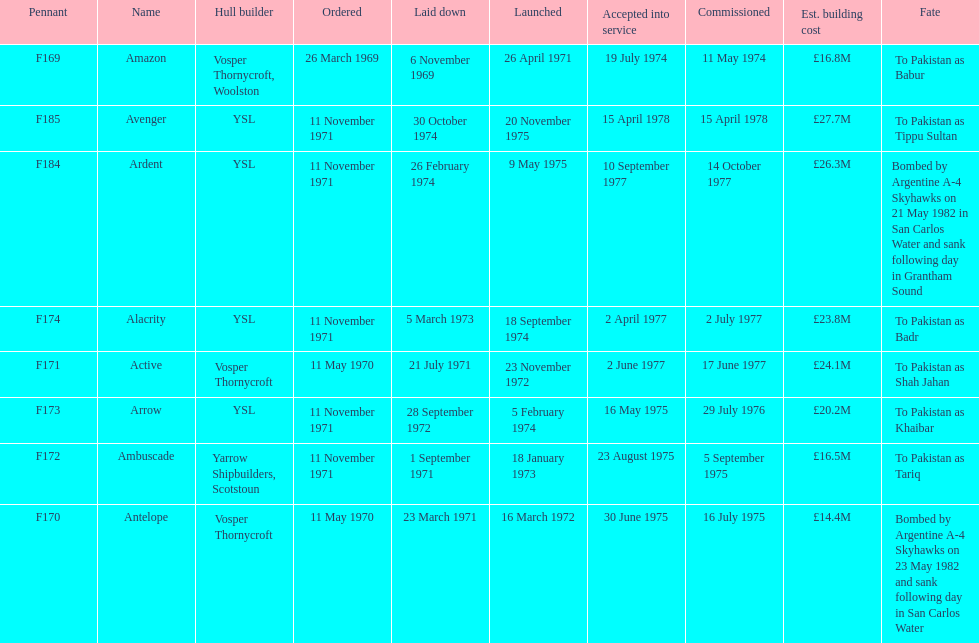Parse the full table. {'header': ['Pennant', 'Name', 'Hull builder', 'Ordered', 'Laid down', 'Launched', 'Accepted into service', 'Commissioned', 'Est. building cost', 'Fate'], 'rows': [['F169', 'Amazon', 'Vosper Thornycroft, Woolston', '26 March 1969', '6 November 1969', '26 April 1971', '19 July 1974', '11 May 1974', '£16.8M', 'To Pakistan as Babur'], ['F185', 'Avenger', 'YSL', '11 November 1971', '30 October 1974', '20 November 1975', '15 April 1978', '15 April 1978', '£27.7M', 'To Pakistan as Tippu Sultan'], ['F184', 'Ardent', 'YSL', '11 November 1971', '26 February 1974', '9 May 1975', '10 September 1977', '14 October 1977', '£26.3M', 'Bombed by Argentine A-4 Skyhawks on 21 May 1982 in San Carlos Water and sank following day in Grantham Sound'], ['F174', 'Alacrity', 'YSL', '11 November 1971', '5 March 1973', '18 September 1974', '2 April 1977', '2 July 1977', '£23.8M', 'To Pakistan as Badr'], ['F171', 'Active', 'Vosper Thornycroft', '11 May 1970', '21 July 1971', '23 November 1972', '2 June 1977', '17 June 1977', '£24.1M', 'To Pakistan as Shah Jahan'], ['F173', 'Arrow', 'YSL', '11 November 1971', '28 September 1972', '5 February 1974', '16 May 1975', '29 July 1976', '£20.2M', 'To Pakistan as Khaibar'], ['F172', 'Ambuscade', 'Yarrow Shipbuilders, Scotstoun', '11 November 1971', '1 September 1971', '18 January 1973', '23 August 1975', '5 September 1975', '£16.5M', 'To Pakistan as Tariq'], ['F170', 'Antelope', 'Vosper Thornycroft', '11 May 1970', '23 March 1971', '16 March 1972', '30 June 1975', '16 July 1975', '£14.4M', 'Bombed by Argentine A-4 Skyhawks on 23 May 1982 and sank following day in San Carlos Water']]} What is the next pennant after f172? F173. 